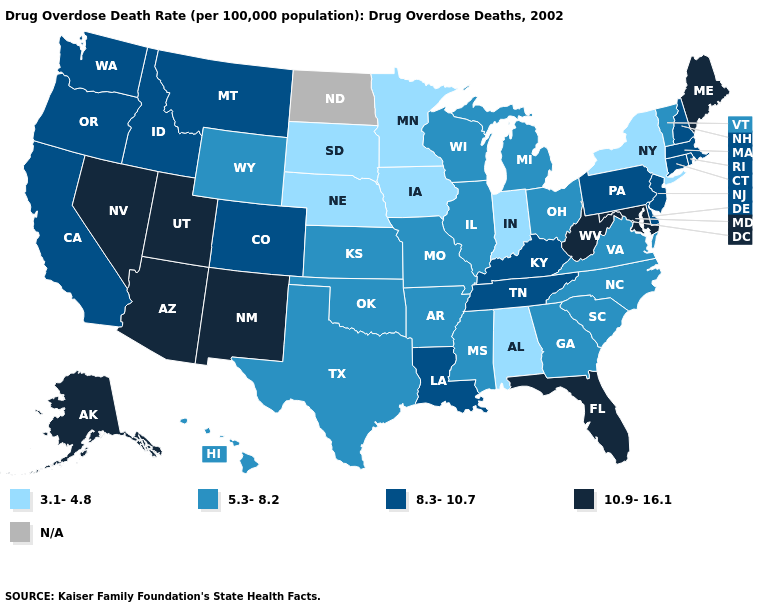What is the highest value in states that border Indiana?
Answer briefly. 8.3-10.7. How many symbols are there in the legend?
Be succinct. 5. Name the states that have a value in the range N/A?
Quick response, please. North Dakota. Name the states that have a value in the range 8.3-10.7?
Write a very short answer. California, Colorado, Connecticut, Delaware, Idaho, Kentucky, Louisiana, Massachusetts, Montana, New Hampshire, New Jersey, Oregon, Pennsylvania, Rhode Island, Tennessee, Washington. Does Kentucky have the lowest value in the South?
Write a very short answer. No. Name the states that have a value in the range 5.3-8.2?
Answer briefly. Arkansas, Georgia, Hawaii, Illinois, Kansas, Michigan, Mississippi, Missouri, North Carolina, Ohio, Oklahoma, South Carolina, Texas, Vermont, Virginia, Wisconsin, Wyoming. What is the value of South Carolina?
Quick response, please. 5.3-8.2. Name the states that have a value in the range 5.3-8.2?
Concise answer only. Arkansas, Georgia, Hawaii, Illinois, Kansas, Michigan, Mississippi, Missouri, North Carolina, Ohio, Oklahoma, South Carolina, Texas, Vermont, Virginia, Wisconsin, Wyoming. Among the states that border California , does Arizona have the highest value?
Short answer required. Yes. Name the states that have a value in the range N/A?
Concise answer only. North Dakota. Does the map have missing data?
Quick response, please. Yes. Which states have the lowest value in the West?
Quick response, please. Hawaii, Wyoming. Does New Mexico have the lowest value in the West?
Short answer required. No. Does Arkansas have the lowest value in the USA?
Give a very brief answer. No. Does Alaska have the highest value in the USA?
Write a very short answer. Yes. 